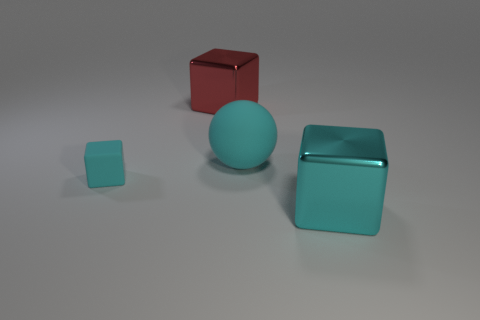Add 1 cyan cubes. How many objects exist? 5 Subtract all blocks. How many objects are left? 1 Subtract all large cyan metal cubes. Subtract all small gray objects. How many objects are left? 3 Add 1 cyan cubes. How many cyan cubes are left? 3 Add 3 purple shiny spheres. How many purple shiny spheres exist? 3 Subtract 0 brown spheres. How many objects are left? 4 